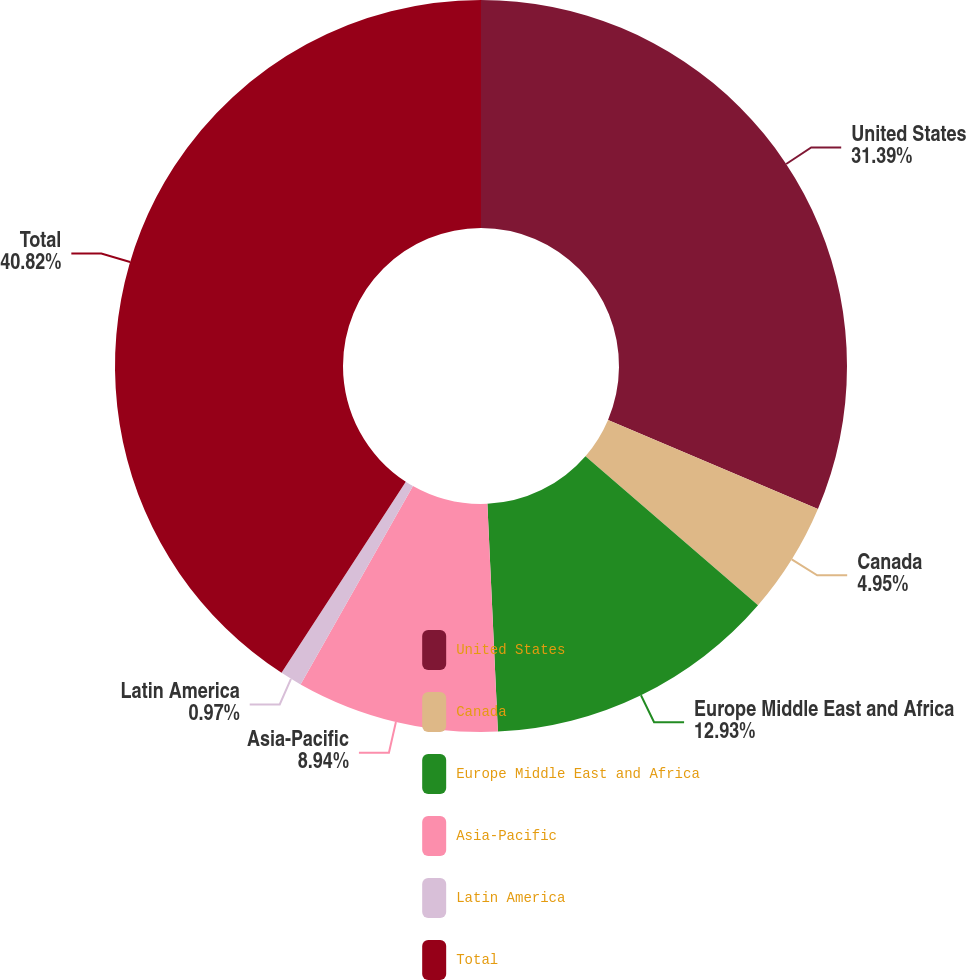<chart> <loc_0><loc_0><loc_500><loc_500><pie_chart><fcel>United States<fcel>Canada<fcel>Europe Middle East and Africa<fcel>Asia-Pacific<fcel>Latin America<fcel>Total<nl><fcel>31.39%<fcel>4.95%<fcel>12.93%<fcel>8.94%<fcel>0.97%<fcel>40.83%<nl></chart> 